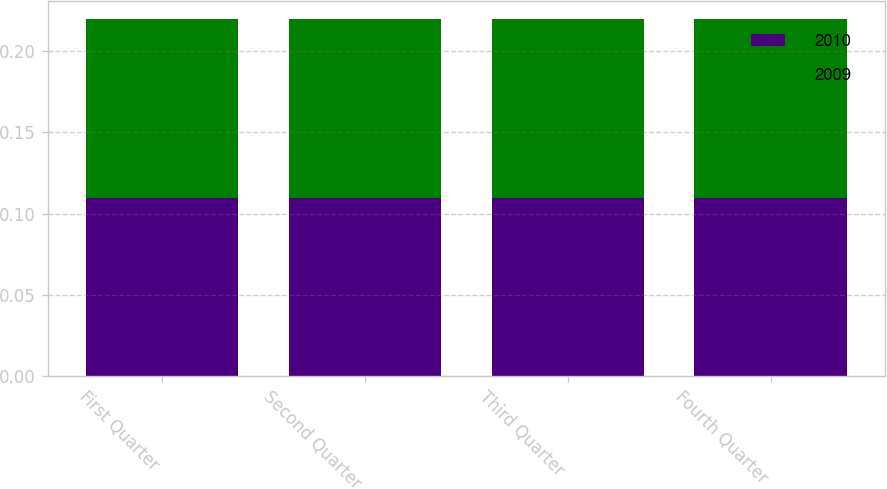Convert chart to OTSL. <chart><loc_0><loc_0><loc_500><loc_500><stacked_bar_chart><ecel><fcel>First Quarter<fcel>Second Quarter<fcel>Third Quarter<fcel>Fourth Quarter<nl><fcel>2010<fcel>0.11<fcel>0.11<fcel>0.11<fcel>0.11<nl><fcel>2009<fcel>0.11<fcel>0.11<fcel>0.11<fcel>0.11<nl></chart> 